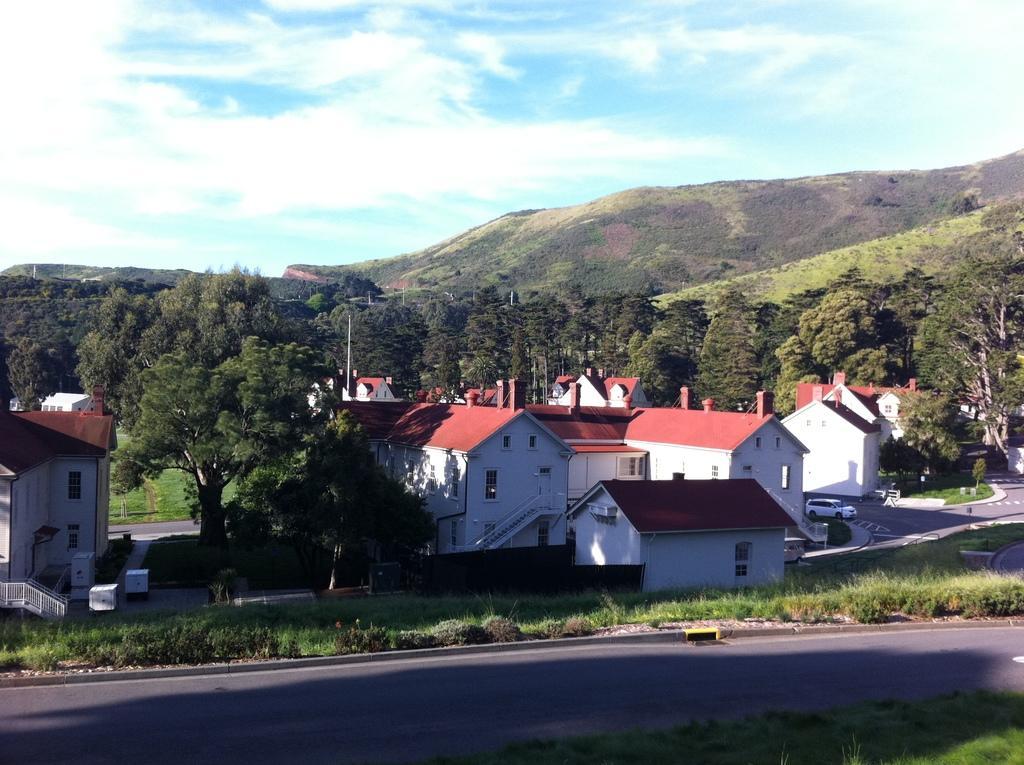Could you give a brief overview of what you see in this image? In this image there is the sky, there are clouds in the sky, there are mountains truncated towards the right of the image, there are trees, there are trees truncated towards the right of the image, there are trees truncated towards the left of the image, there are houses, there is a house truncated towards the left of the image, there is grass, there is the road, there is the grass truncated towards the bottom of the image, there is a vehicle on the road, there is a pole. 